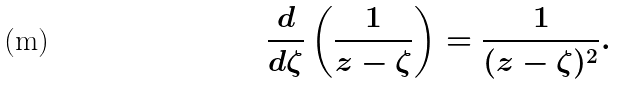Convert formula to latex. <formula><loc_0><loc_0><loc_500><loc_500>\frac { d } { d \zeta } \left ( \frac { 1 } { z - \zeta } \right ) = \frac { 1 } { ( z - \zeta ) ^ { 2 } } .</formula> 